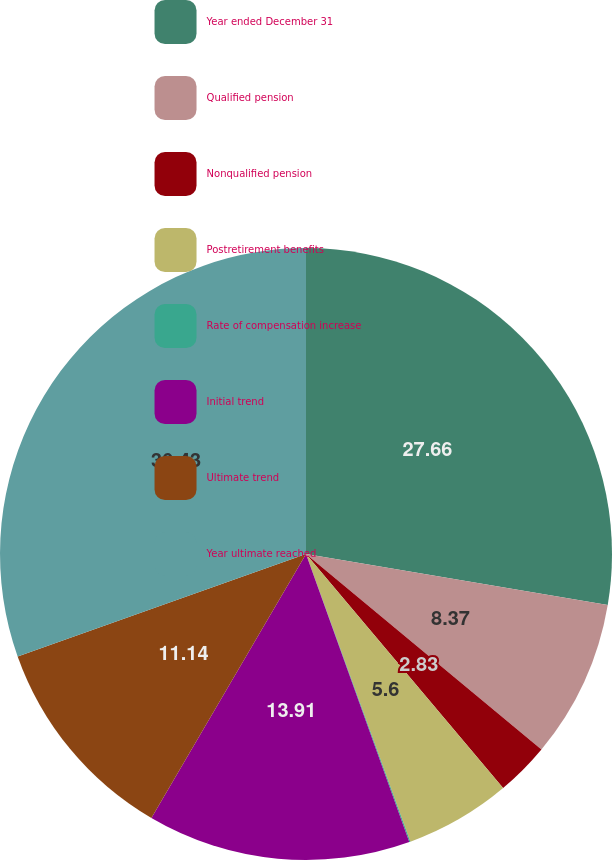Convert chart to OTSL. <chart><loc_0><loc_0><loc_500><loc_500><pie_chart><fcel>Year ended December 31<fcel>Qualified pension<fcel>Nonqualified pension<fcel>Postretirement benefits<fcel>Rate of compensation increase<fcel>Initial trend<fcel>Ultimate trend<fcel>Year ultimate reached<nl><fcel>27.66%<fcel>8.37%<fcel>2.83%<fcel>5.6%<fcel>0.06%<fcel>13.91%<fcel>11.14%<fcel>30.43%<nl></chart> 